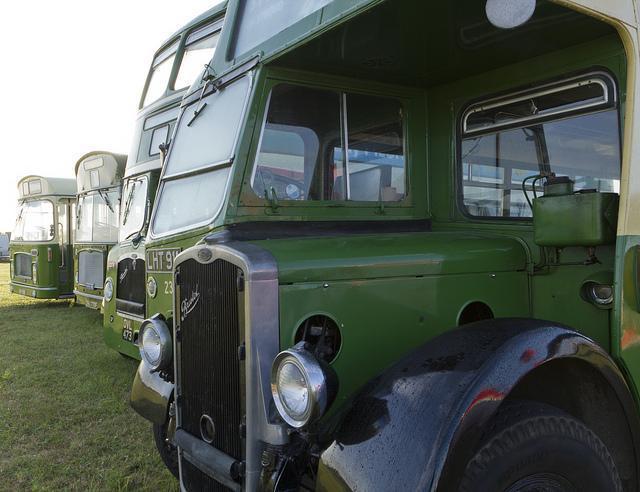How many decks does the bus in the front have?
Give a very brief answer. 2. How many buses are there?
Give a very brief answer. 4. How many people are wearing sunglasses in this photo?
Give a very brief answer. 0. 